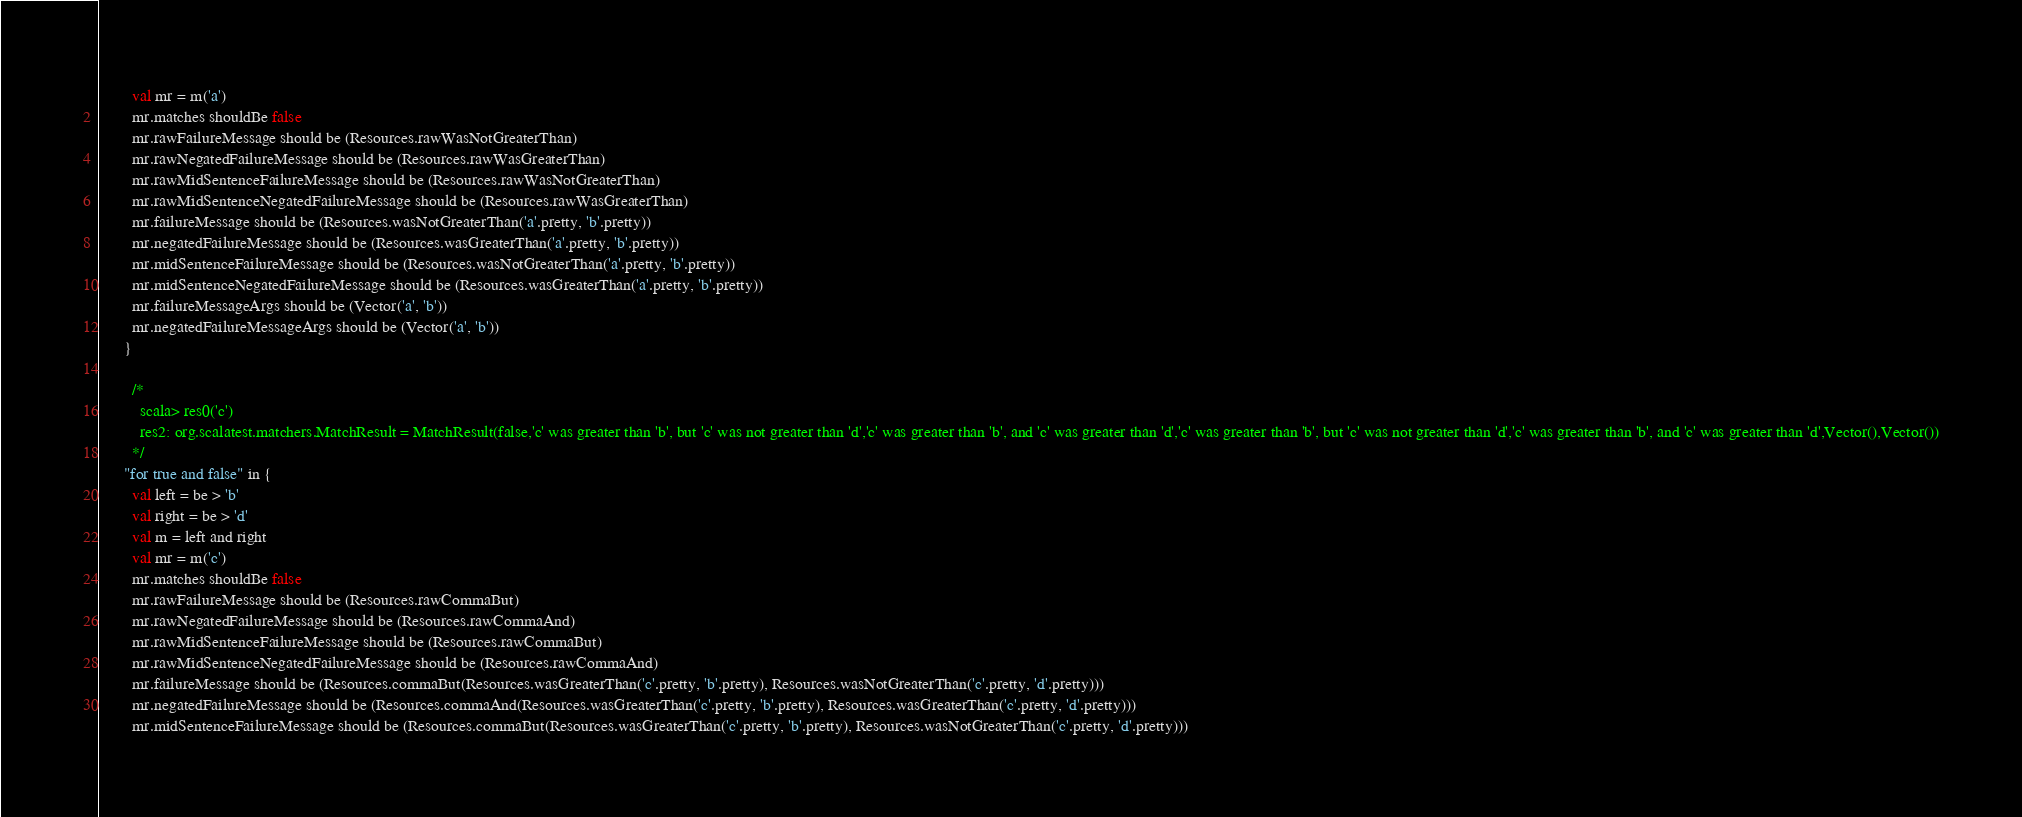Convert code to text. <code><loc_0><loc_0><loc_500><loc_500><_Scala_>        val mr = m('a')
        mr.matches shouldBe false
        mr.rawFailureMessage should be (Resources.rawWasNotGreaterThan)
        mr.rawNegatedFailureMessage should be (Resources.rawWasGreaterThan)
        mr.rawMidSentenceFailureMessage should be (Resources.rawWasNotGreaterThan)
        mr.rawMidSentenceNegatedFailureMessage should be (Resources.rawWasGreaterThan)
        mr.failureMessage should be (Resources.wasNotGreaterThan('a'.pretty, 'b'.pretty))
        mr.negatedFailureMessage should be (Resources.wasGreaterThan('a'.pretty, 'b'.pretty))
        mr.midSentenceFailureMessage should be (Resources.wasNotGreaterThan('a'.pretty, 'b'.pretty))
        mr.midSentenceNegatedFailureMessage should be (Resources.wasGreaterThan('a'.pretty, 'b'.pretty))
        mr.failureMessageArgs should be (Vector('a', 'b'))
        mr.negatedFailureMessageArgs should be (Vector('a', 'b'))
      }

        /*
          scala> res0('c')
          res2: org.scalatest.matchers.MatchResult = MatchResult(false,'c' was greater than 'b', but 'c' was not greater than 'd','c' was greater than 'b', and 'c' was greater than 'd','c' was greater than 'b', but 'c' was not greater than 'd','c' was greater than 'b', and 'c' was greater than 'd',Vector(),Vector())
        */
      "for true and false" in {
        val left = be > 'b'
        val right = be > 'd'
        val m = left and right
        val mr = m('c')
        mr.matches shouldBe false
        mr.rawFailureMessage should be (Resources.rawCommaBut)
        mr.rawNegatedFailureMessage should be (Resources.rawCommaAnd)
        mr.rawMidSentenceFailureMessage should be (Resources.rawCommaBut)
        mr.rawMidSentenceNegatedFailureMessage should be (Resources.rawCommaAnd)
        mr.failureMessage should be (Resources.commaBut(Resources.wasGreaterThan('c'.pretty, 'b'.pretty), Resources.wasNotGreaterThan('c'.pretty, 'd'.pretty)))
        mr.negatedFailureMessage should be (Resources.commaAnd(Resources.wasGreaterThan('c'.pretty, 'b'.pretty), Resources.wasGreaterThan('c'.pretty, 'd'.pretty)))
        mr.midSentenceFailureMessage should be (Resources.commaBut(Resources.wasGreaterThan('c'.pretty, 'b'.pretty), Resources.wasNotGreaterThan('c'.pretty, 'd'.pretty)))</code> 